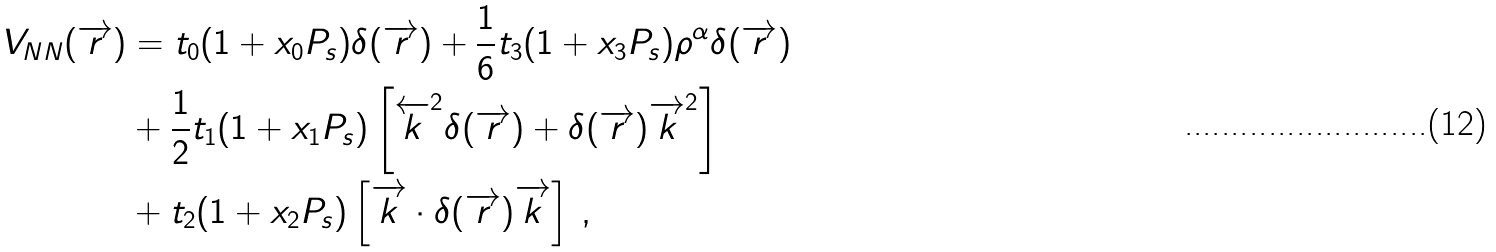<formula> <loc_0><loc_0><loc_500><loc_500>V _ { N N } ( { \overrightarrow { r } } ) & = t _ { 0 } ( 1 + x _ { 0 } P _ { s } ) \delta ( { \overrightarrow { r } } ) + \frac { 1 } { 6 } t _ { 3 } ( 1 + x _ { 3 } P _ { s } ) \rho ^ { \alpha } \delta ( { \overrightarrow { r } } ) \\ & + \frac { 1 } { 2 } t _ { 1 } ( 1 + x _ { 1 } P _ { s } ) \left [ { \overleftarrow { k } } ^ { 2 } \delta ( { \overrightarrow { r } } ) + \delta ( { \overrightarrow { r } } ) { \overrightarrow { k } } ^ { 2 } \right ] \\ & + t _ { 2 } ( 1 + x _ { 2 } P _ { s } ) \left [ { \overrightarrow { k } } \cdot \delta ( { \overrightarrow { r } } ) { \overrightarrow { k } } \right ] \, ,</formula> 